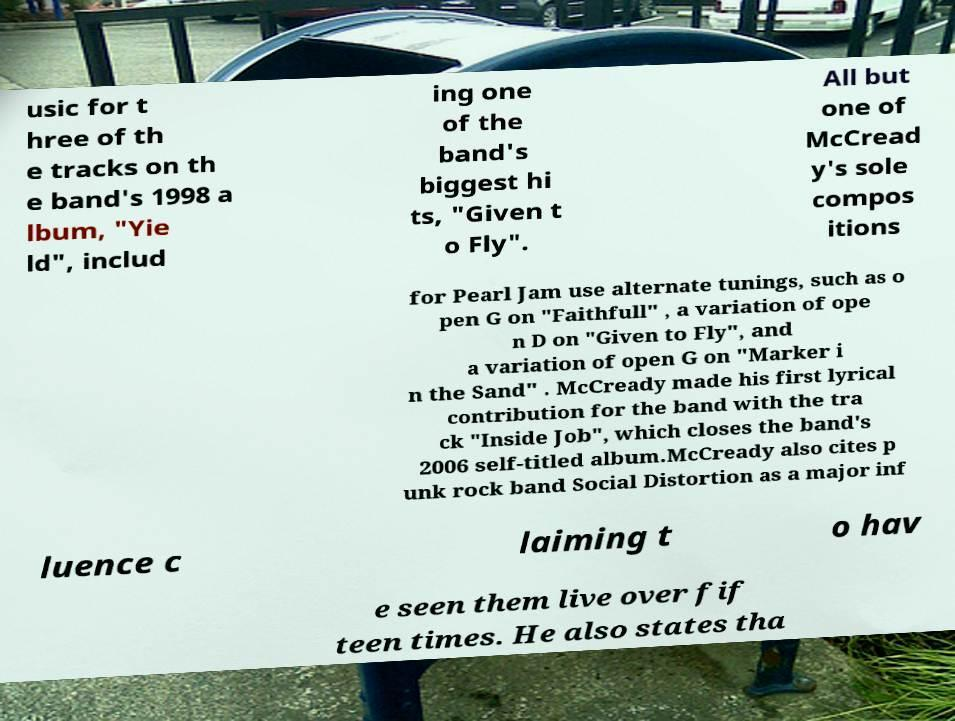Please identify and transcribe the text found in this image. usic for t hree of th e tracks on th e band's 1998 a lbum, "Yie ld", includ ing one of the band's biggest hi ts, "Given t o Fly". All but one of McCread y's sole compos itions for Pearl Jam use alternate tunings, such as o pen G on "Faithfull" , a variation of ope n D on "Given to Fly", and a variation of open G on "Marker i n the Sand" . McCready made his first lyrical contribution for the band with the tra ck "Inside Job", which closes the band's 2006 self-titled album.McCready also cites p unk rock band Social Distortion as a major inf luence c laiming t o hav e seen them live over fif teen times. He also states tha 